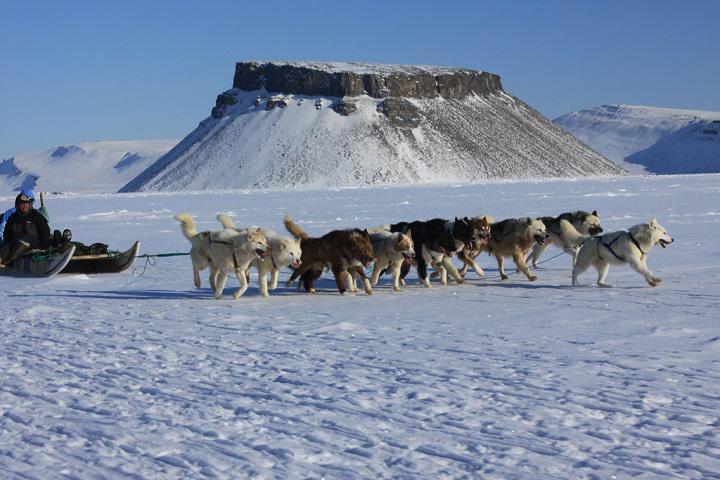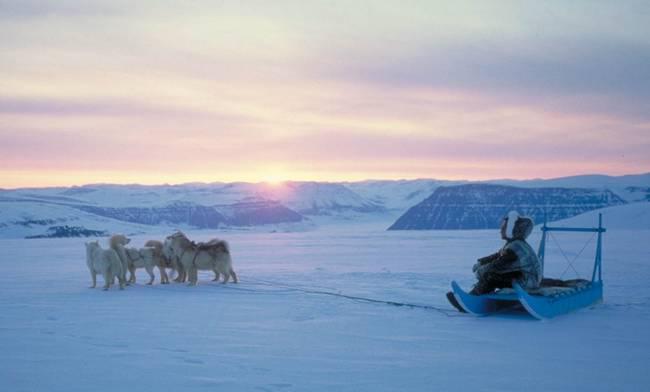The first image is the image on the left, the second image is the image on the right. Considering the images on both sides, is "In the left image, the sled dog team is taking a break." valid? Answer yes or no. No. The first image is the image on the left, the second image is the image on the right. Given the left and right images, does the statement "In one of the images the photographer's sled is being pulled by dogs." hold true? Answer yes or no. No. 